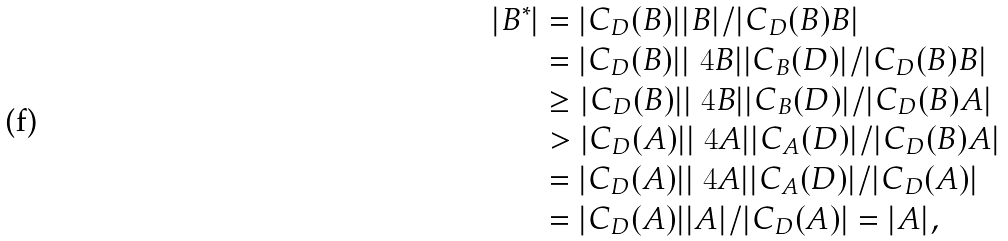Convert formula to latex. <formula><loc_0><loc_0><loc_500><loc_500>| B ^ { * } | & = | C _ { D } ( B ) | | B | / | C _ { D } ( B ) B | \\ & = | C _ { D } ( B ) | | \ 4 B | | C _ { B } ( D ) | / | C _ { D } ( B ) B | \\ & \geq | C _ { D } ( B ) | | \ 4 B | | C _ { B } ( D ) | / | C _ { D } ( B ) A | \\ & > | C _ { D } ( A ) | | \ 4 A | | C _ { A } ( D ) | / | C _ { D } ( B ) A | \\ & = | C _ { D } ( A ) | | \ 4 A | | C _ { A } ( D ) | / | C _ { D } ( A ) | \\ & = | C _ { D } ( A ) | | A | / | C _ { D } ( A ) | = | A | , \\</formula> 